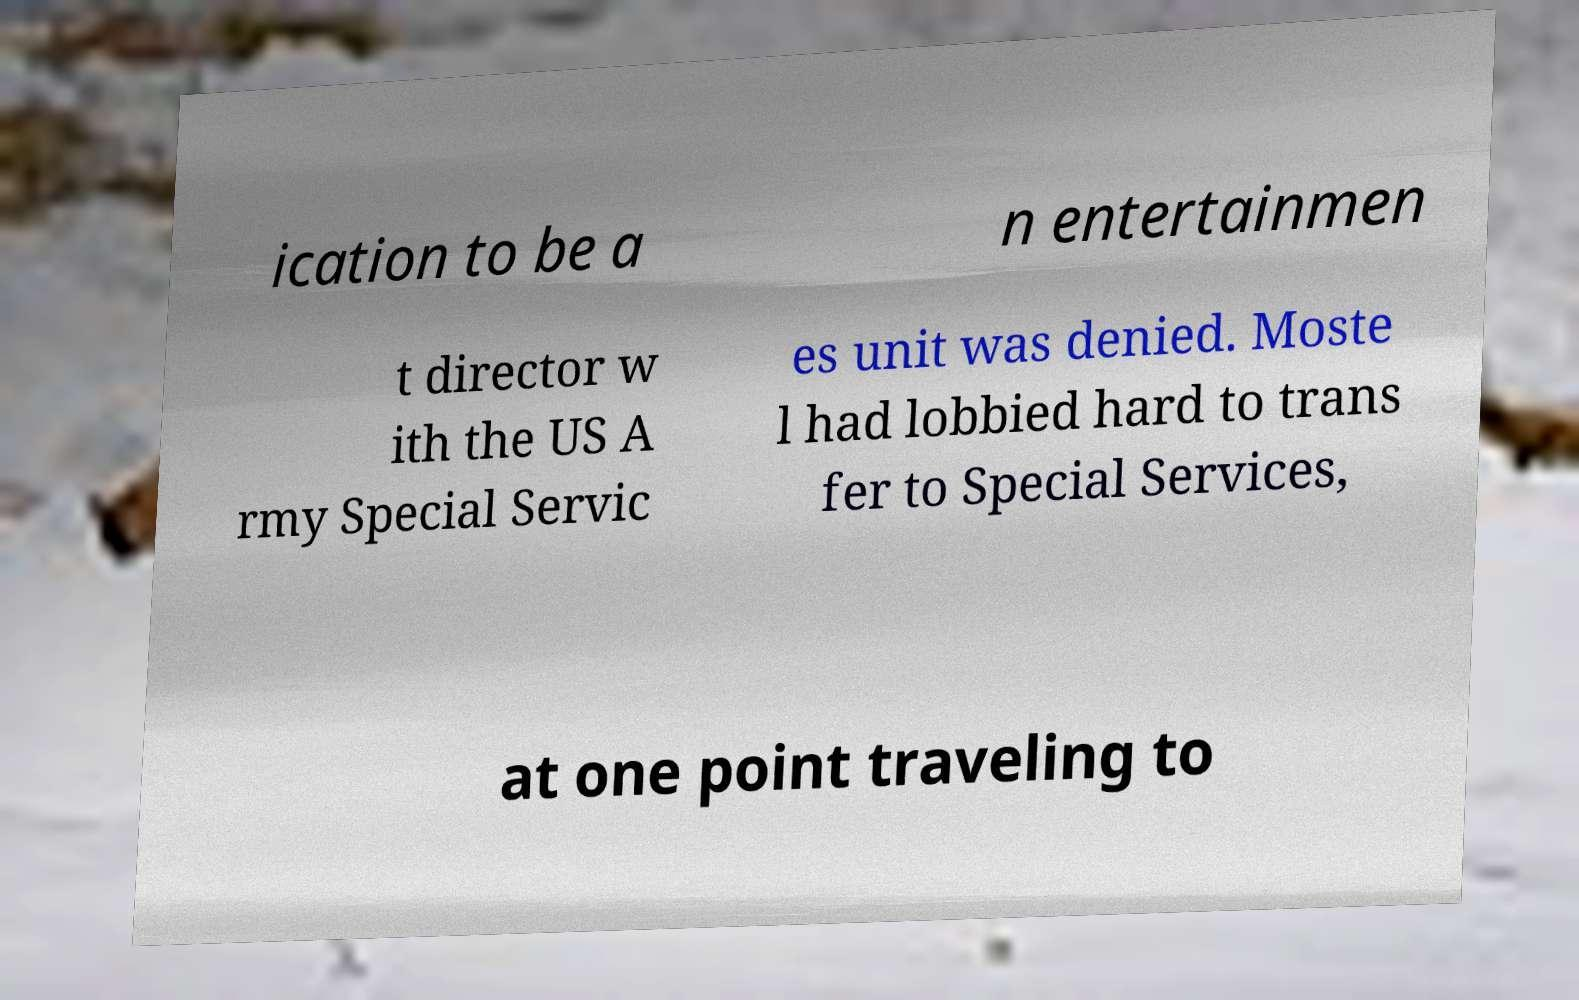What messages or text are displayed in this image? I need them in a readable, typed format. ication to be a n entertainmen t director w ith the US A rmy Special Servic es unit was denied. Moste l had lobbied hard to trans fer to Special Services, at one point traveling to 